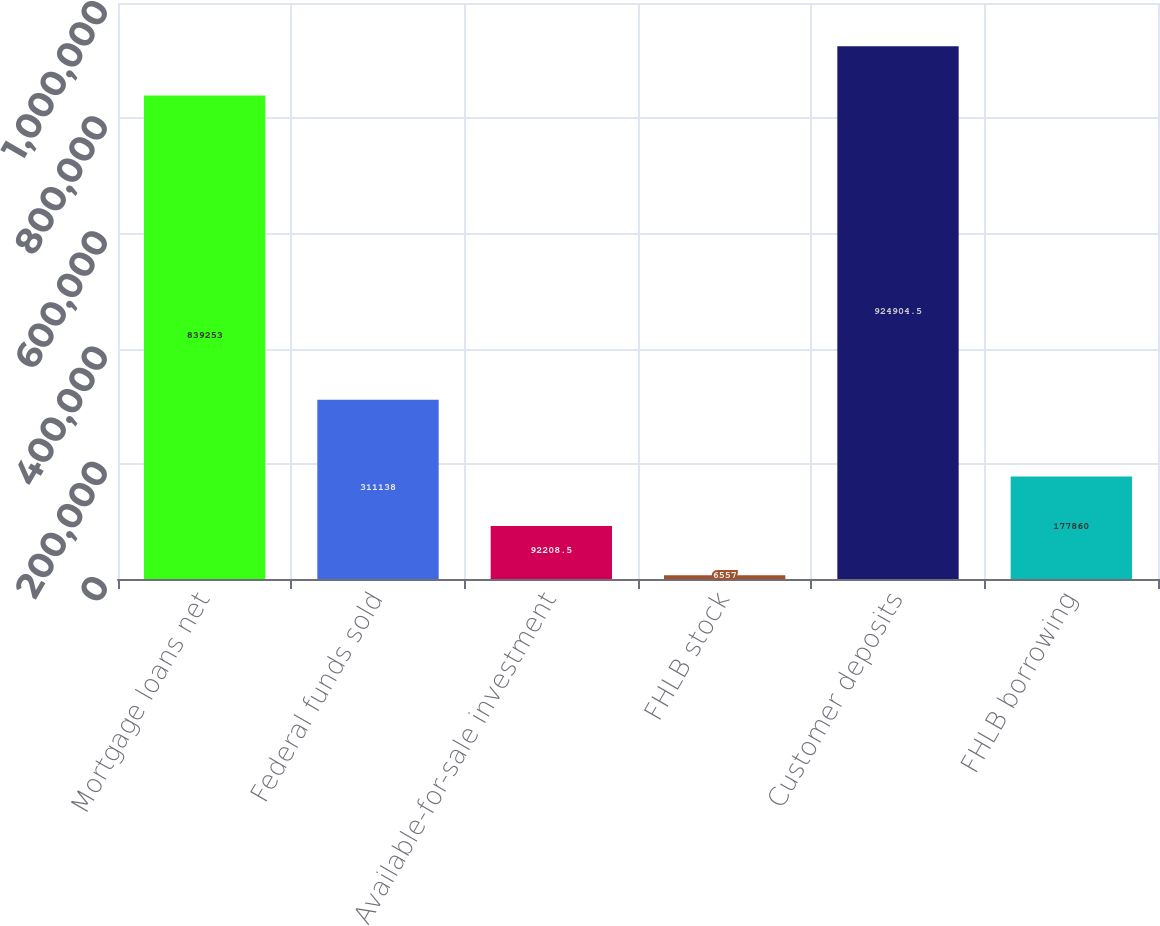Convert chart. <chart><loc_0><loc_0><loc_500><loc_500><bar_chart><fcel>Mortgage loans net<fcel>Federal funds sold<fcel>Available-for-sale investment<fcel>FHLB stock<fcel>Customer deposits<fcel>FHLB borrowing<nl><fcel>839253<fcel>311138<fcel>92208.5<fcel>6557<fcel>924904<fcel>177860<nl></chart> 